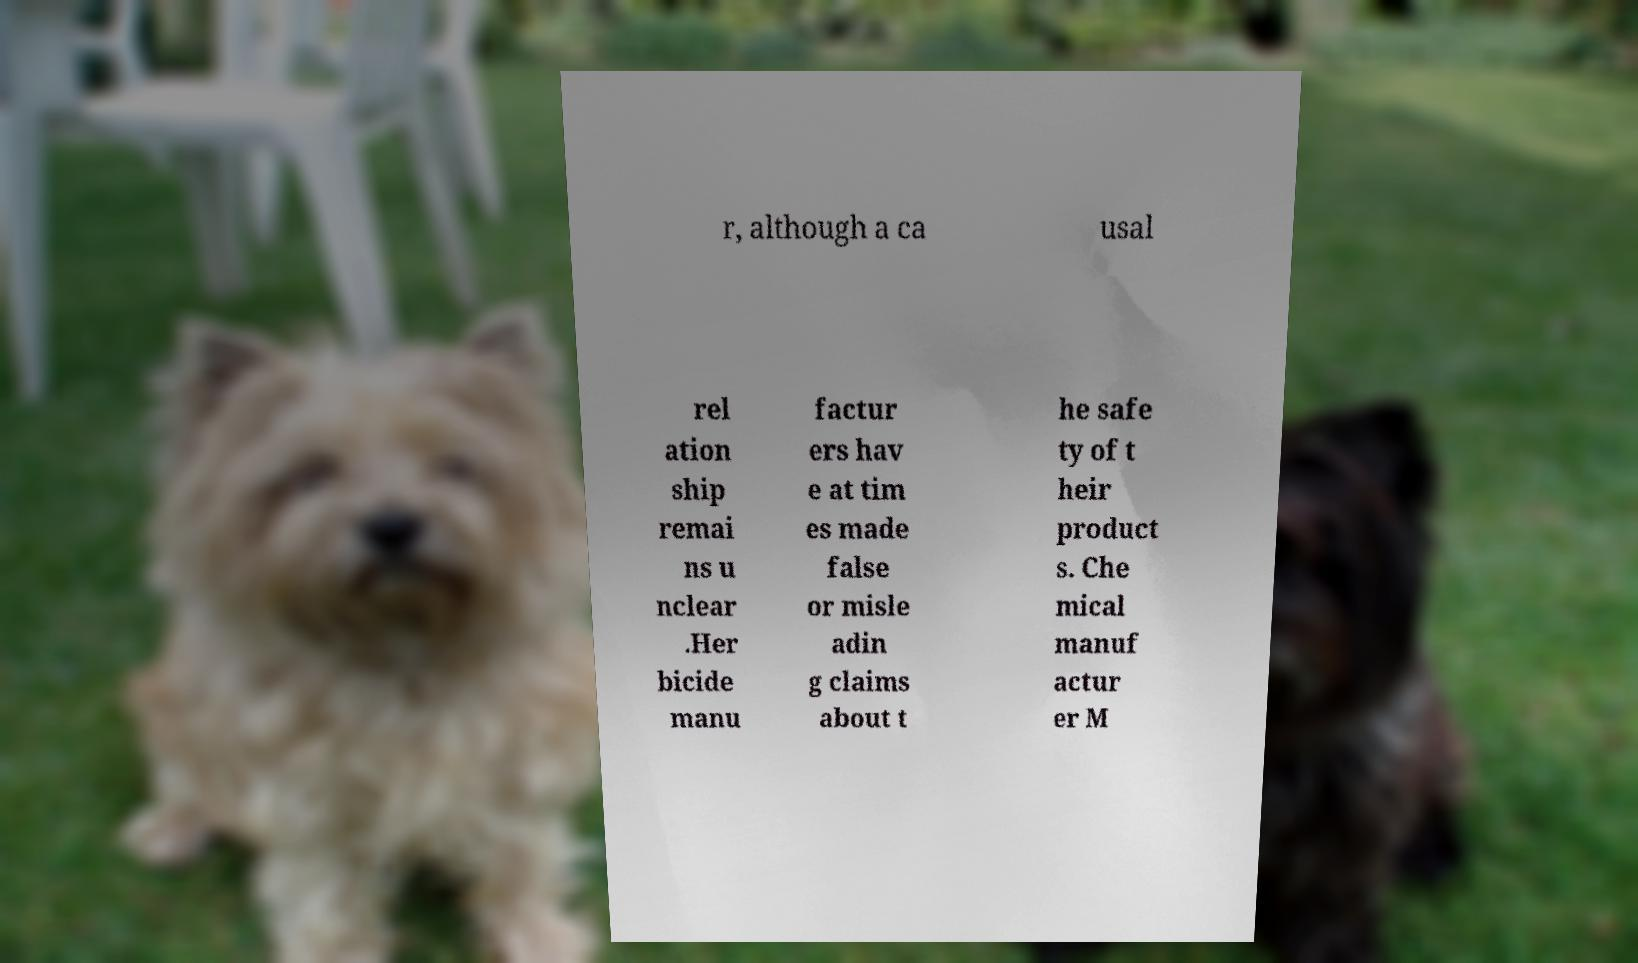Could you assist in decoding the text presented in this image and type it out clearly? r, although a ca usal rel ation ship remai ns u nclear .Her bicide manu factur ers hav e at tim es made false or misle adin g claims about t he safe ty of t heir product s. Che mical manuf actur er M 